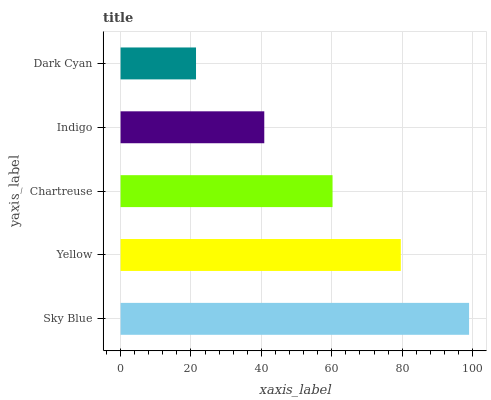Is Dark Cyan the minimum?
Answer yes or no. Yes. Is Sky Blue the maximum?
Answer yes or no. Yes. Is Yellow the minimum?
Answer yes or no. No. Is Yellow the maximum?
Answer yes or no. No. Is Sky Blue greater than Yellow?
Answer yes or no. Yes. Is Yellow less than Sky Blue?
Answer yes or no. Yes. Is Yellow greater than Sky Blue?
Answer yes or no. No. Is Sky Blue less than Yellow?
Answer yes or no. No. Is Chartreuse the high median?
Answer yes or no. Yes. Is Chartreuse the low median?
Answer yes or no. Yes. Is Dark Cyan the high median?
Answer yes or no. No. Is Sky Blue the low median?
Answer yes or no. No. 